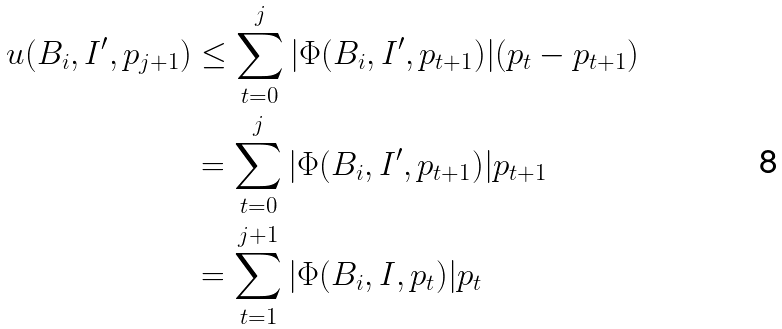Convert formula to latex. <formula><loc_0><loc_0><loc_500><loc_500>\ u ( B _ { i } , I ^ { \prime } , p _ { j + 1 } ) & \leq \sum _ { t = 0 } ^ { j } | \Phi ( B _ { i } , I ^ { \prime } , p _ { t + 1 } ) | ( p _ { t } - p _ { t + 1 } ) \\ & = \sum _ { t = 0 } ^ { j } | \Phi ( B _ { i } , I ^ { \prime } , p _ { t + 1 } ) | p _ { t + 1 } \\ & = \sum _ { t = 1 } ^ { j + 1 } | \Phi ( B _ { i } , I , p _ { t } ) | p _ { t } \\</formula> 